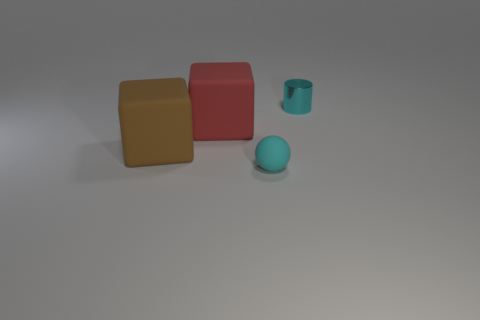What is the material of the block that is in front of the large cube that is on the right side of the big brown matte thing?
Your response must be concise. Rubber. Are there more large red blocks right of the small sphere than brown rubber things left of the large brown object?
Offer a terse response. No. What size is the cyan metallic thing?
Your response must be concise. Small. Is the color of the big object that is left of the red rubber object the same as the small ball?
Your answer should be very brief. No. Are there any other things that are the same shape as the large red rubber thing?
Make the answer very short. Yes. Is there a cylinder on the left side of the small thing in front of the red thing?
Keep it short and to the point. No. Is the number of tiny metal objects on the left side of the shiny cylinder less than the number of brown matte things that are left of the big brown thing?
Your answer should be compact. No. What size is the cyan thing that is in front of the cyan metal cylinder that is behind the big cube left of the red cube?
Ensure brevity in your answer.  Small. Is the size of the cyan object in front of the metal object the same as the red matte block?
Offer a terse response. No. How many other things are made of the same material as the brown cube?
Provide a short and direct response. 2. 